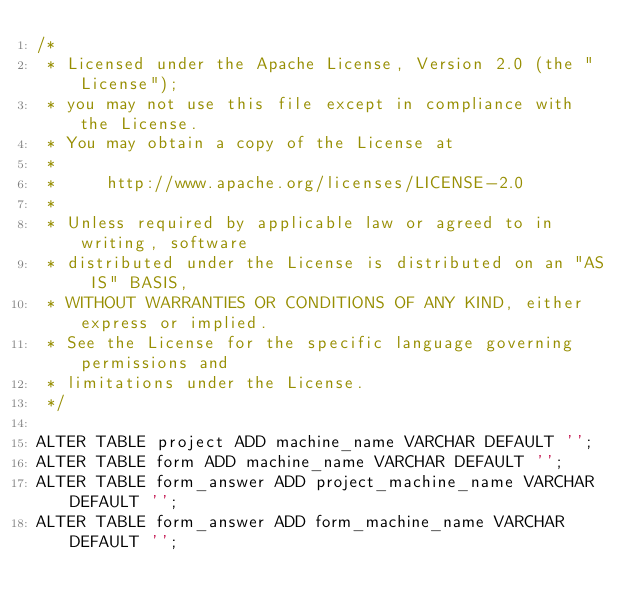Convert code to text. <code><loc_0><loc_0><loc_500><loc_500><_SQL_>/*
 * Licensed under the Apache License, Version 2.0 (the "License");
 * you may not use this file except in compliance with the License.
 * You may obtain a copy of the License at
 *
 *     http://www.apache.org/licenses/LICENSE-2.0
 *
 * Unless required by applicable law or agreed to in writing, software
 * distributed under the License is distributed on an "AS IS" BASIS,
 * WITHOUT WARRANTIES OR CONDITIONS OF ANY KIND, either express or implied.
 * See the License for the specific language governing permissions and
 * limitations under the License.
 */

ALTER TABLE project ADD machine_name VARCHAR DEFAULT '';
ALTER TABLE form ADD machine_name VARCHAR DEFAULT '';
ALTER TABLE form_answer ADD project_machine_name VARCHAR DEFAULT '';
ALTER TABLE form_answer ADD form_machine_name VARCHAR DEFAULT '';
</code> 